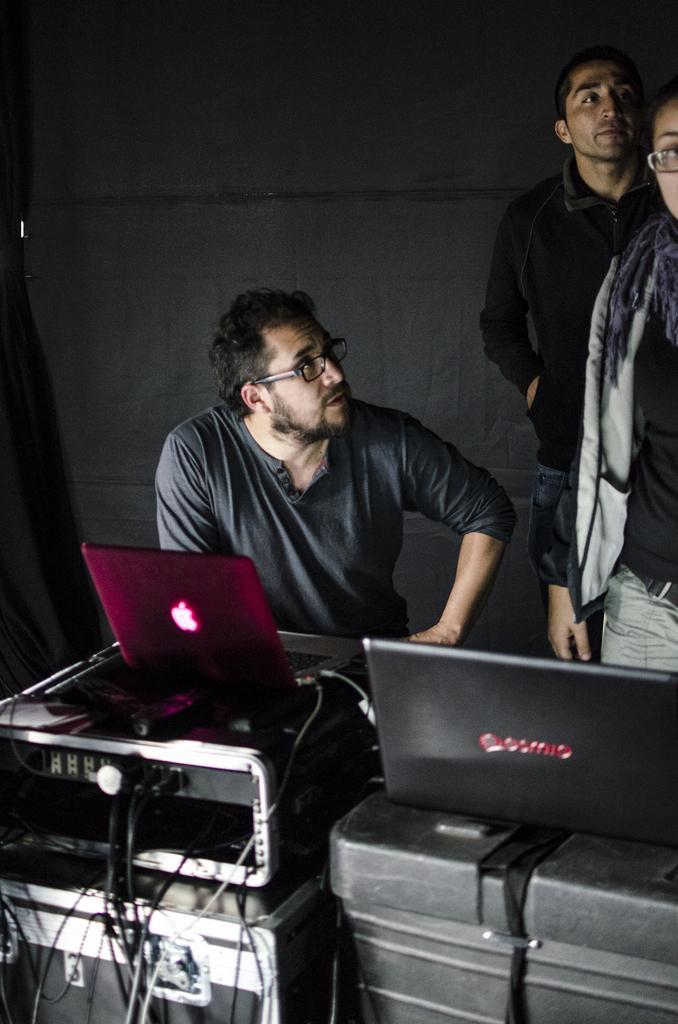Who or what can be seen in the image? There are people in the image. What objects are in front of the people? There are laptops and boxes placed in front of the people. What type of farm can be seen in the background of the image? There is no farm present in the image; it only shows people with laptops and boxes in front of them. 